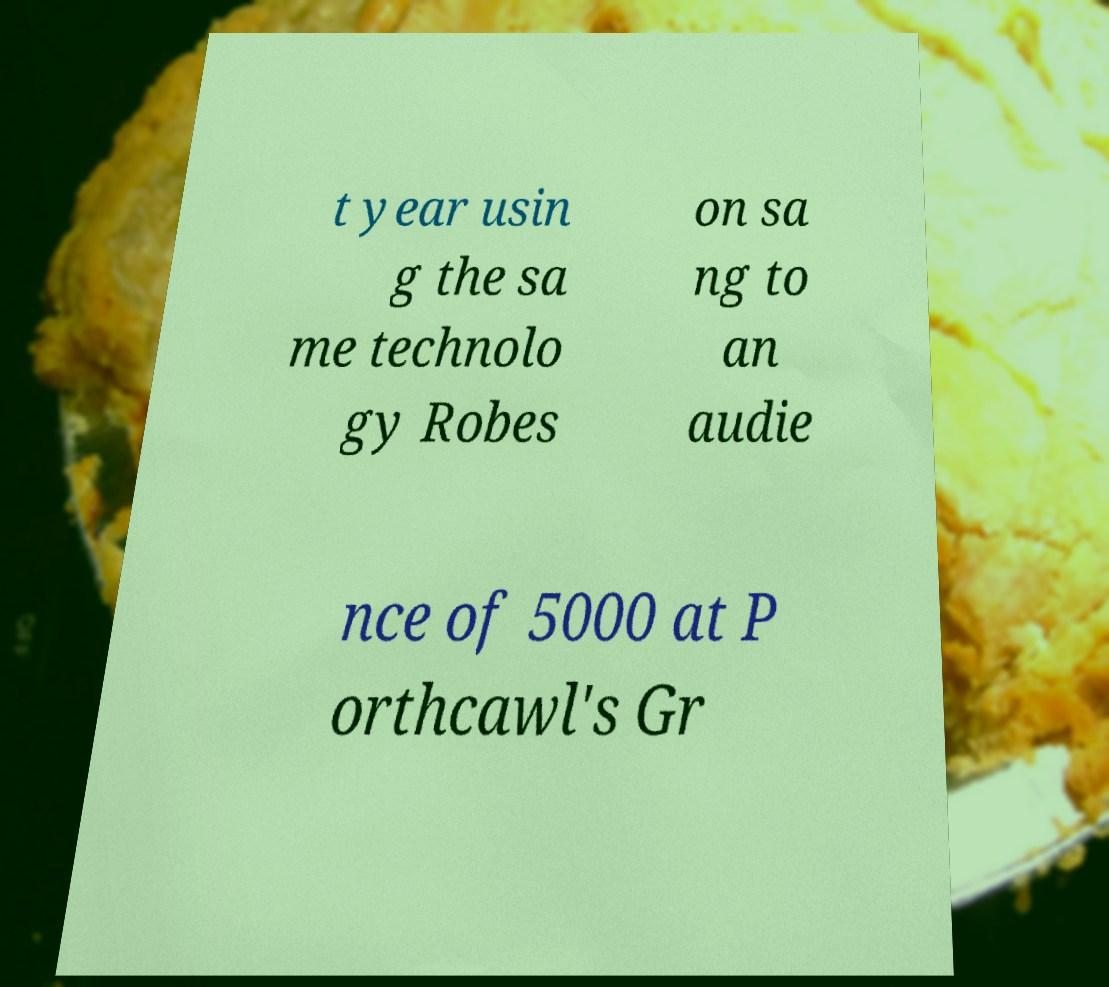Could you extract and type out the text from this image? t year usin g the sa me technolo gy Robes on sa ng to an audie nce of 5000 at P orthcawl's Gr 